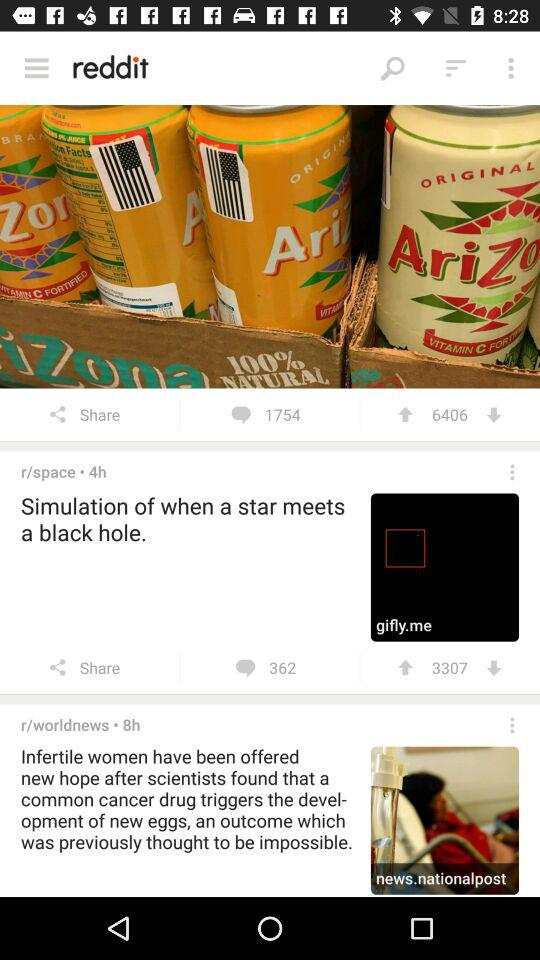How many hours ago was the news "Simulation of when a star meets a black hole." posted? The news "Simulation of when a star meets a black hole." was posted 4 hours ago. 